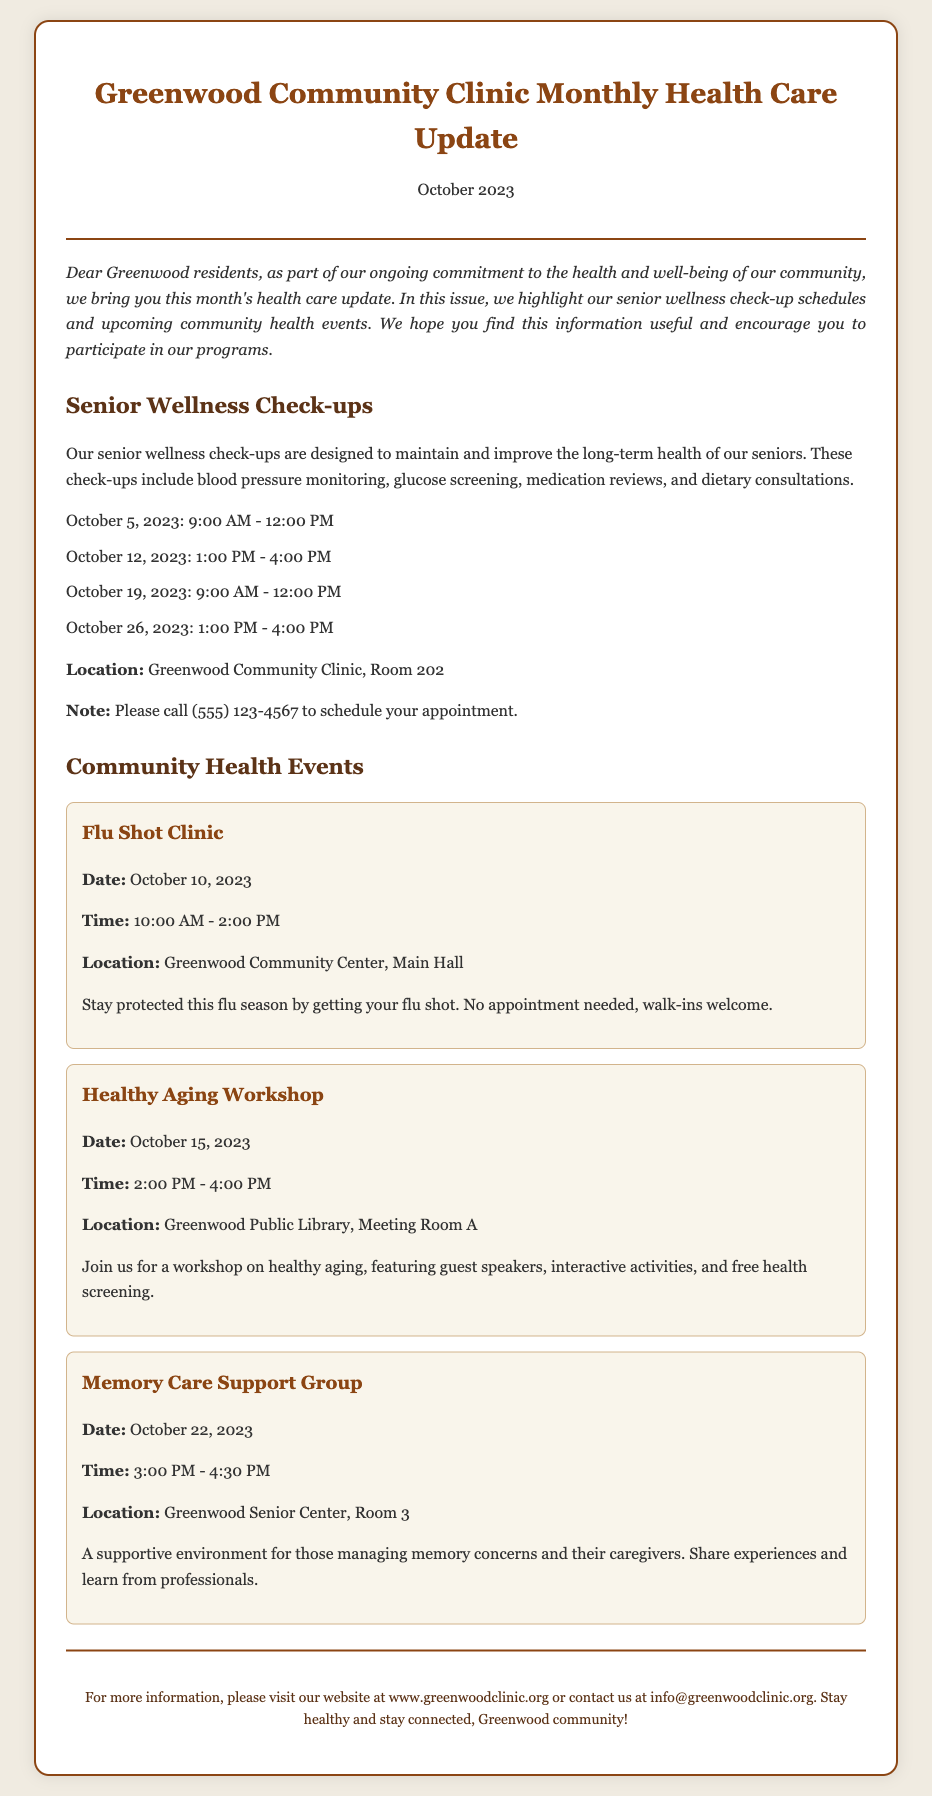What is the title of the document? The title of the document is highlighted at the top of the envelope.
Answer: Greenwood Community Clinic Monthly Health Care Update What is the date of the update? The date is prominently featured below the title in the document.
Answer: October 2023 What is the first scheduled check-up date for seniors? The list of senior wellness check-ups provides the dates in order.
Answer: October 5, 2023 What time does the flu shot clinic start? The flu shot clinic's time is specified in the community health events section.
Answer: 10:00 AM Where is the Healthy Aging Workshop held? The location is mentioned in relation to the event details presented in the document.
Answer: Greenwood Public Library, Meeting Room A What type of services are included in the senior wellness check-ups? The types of services are detailed in the introduction of the section about senior wellness.
Answer: Blood pressure monitoring, glucose screening, medication reviews, dietary consultations How many dates are provided for senior wellness check-ups? The document lists specific dates available for appointments.
Answer: Four dates What is the contact number for scheduling appointments? The contact information is noted at the end of the senior wellness check-ups section.
Answer: (555) 123-4567 What event is scheduled for October 22, 2023? The document lists events with corresponding dates and titles.
Answer: Memory Care Support Group 